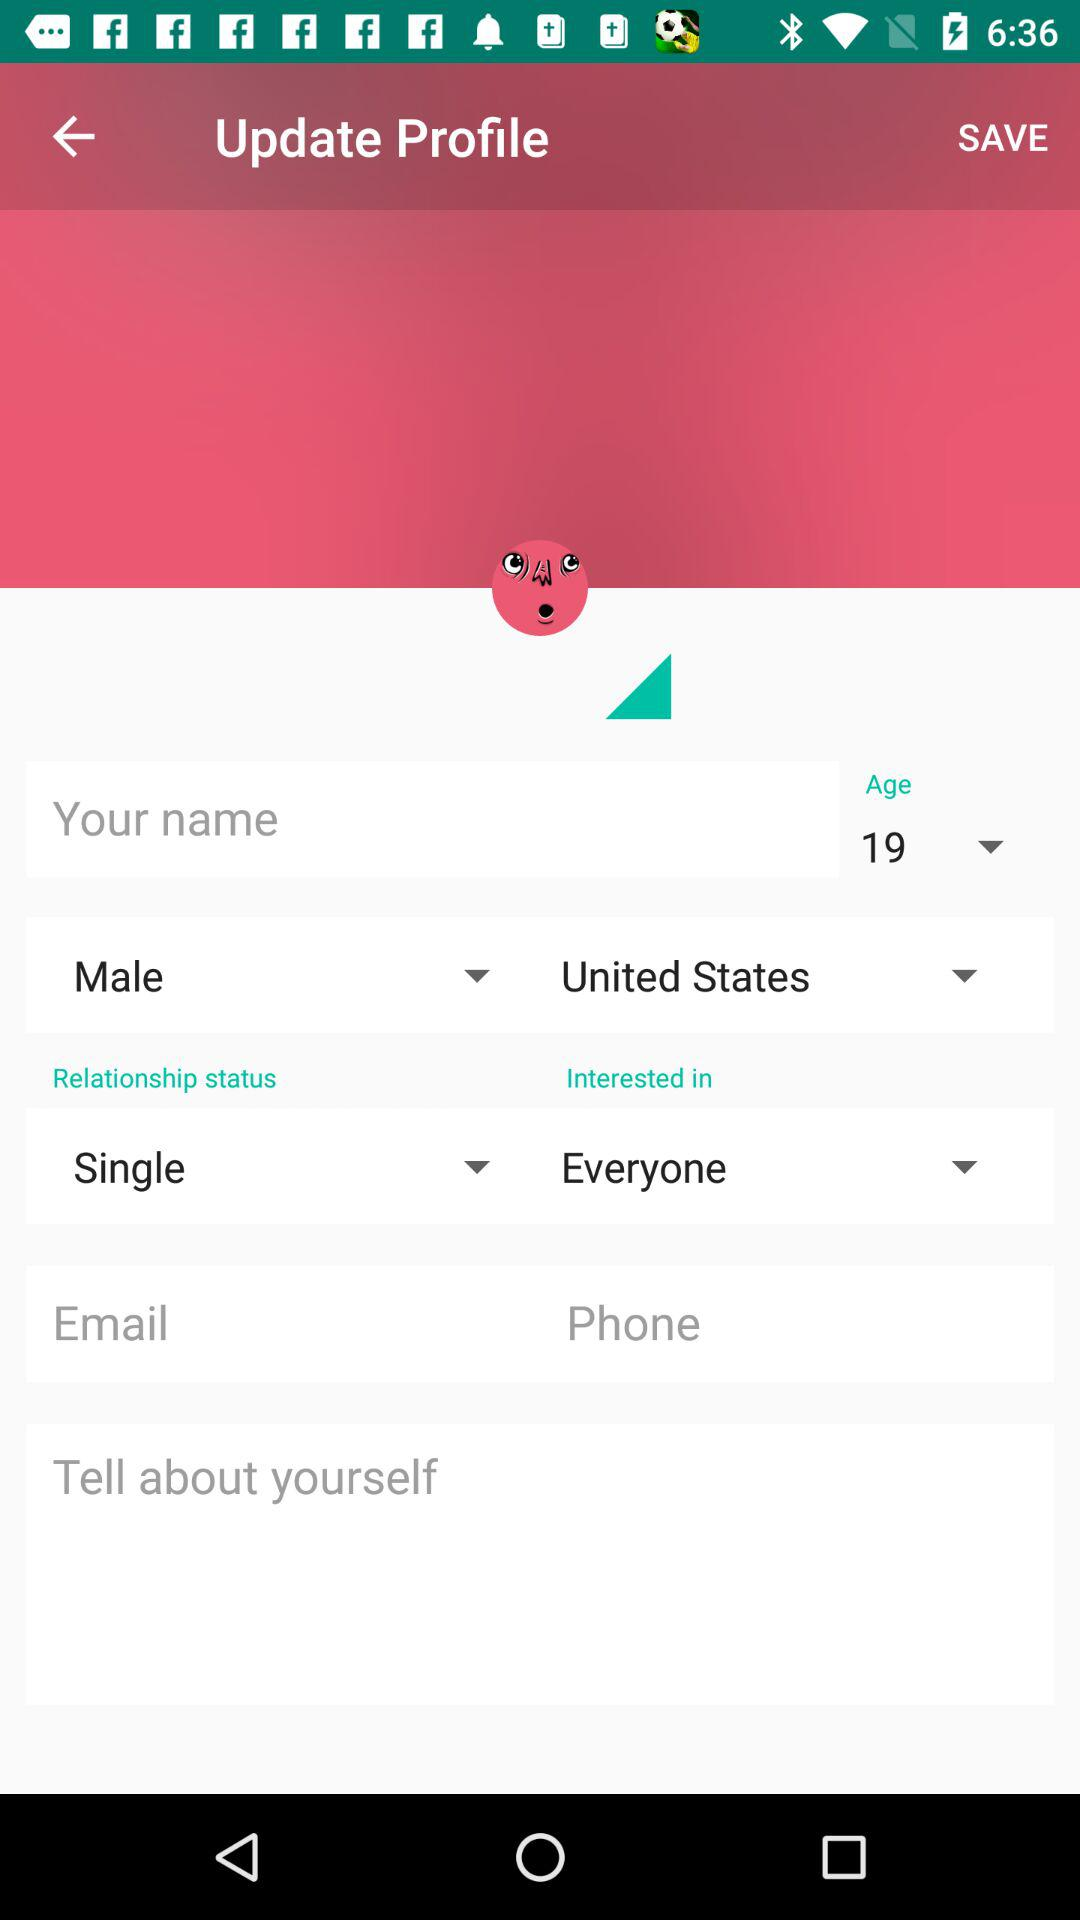What is the user's relationship status? The user's relationship status is single. 